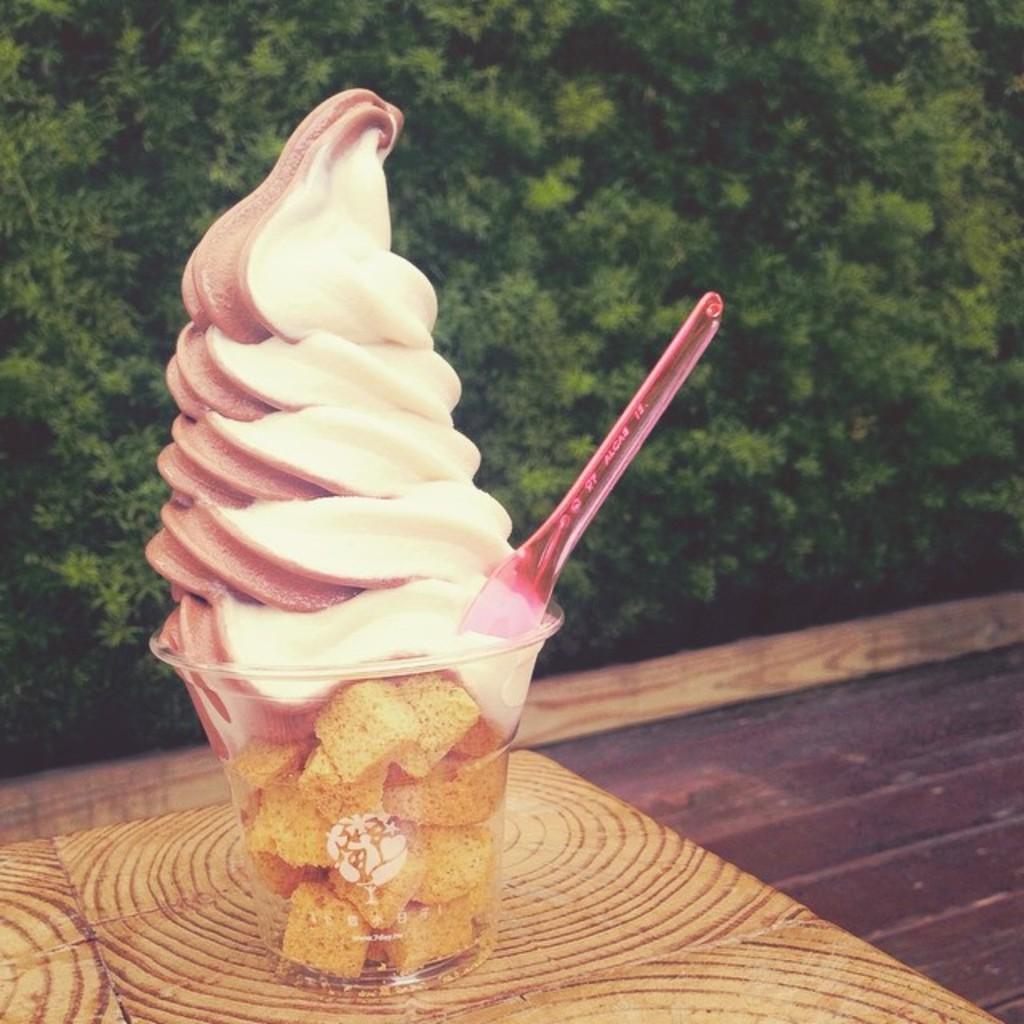Could you give a brief overview of what you see in this image? In this image, we can see a table. On that table, we can see a glass which is filled with some ice cream and some other food item, we can also see a spoon in the glass. In the background, we can see trees, at the bottom, we can see a floor. 